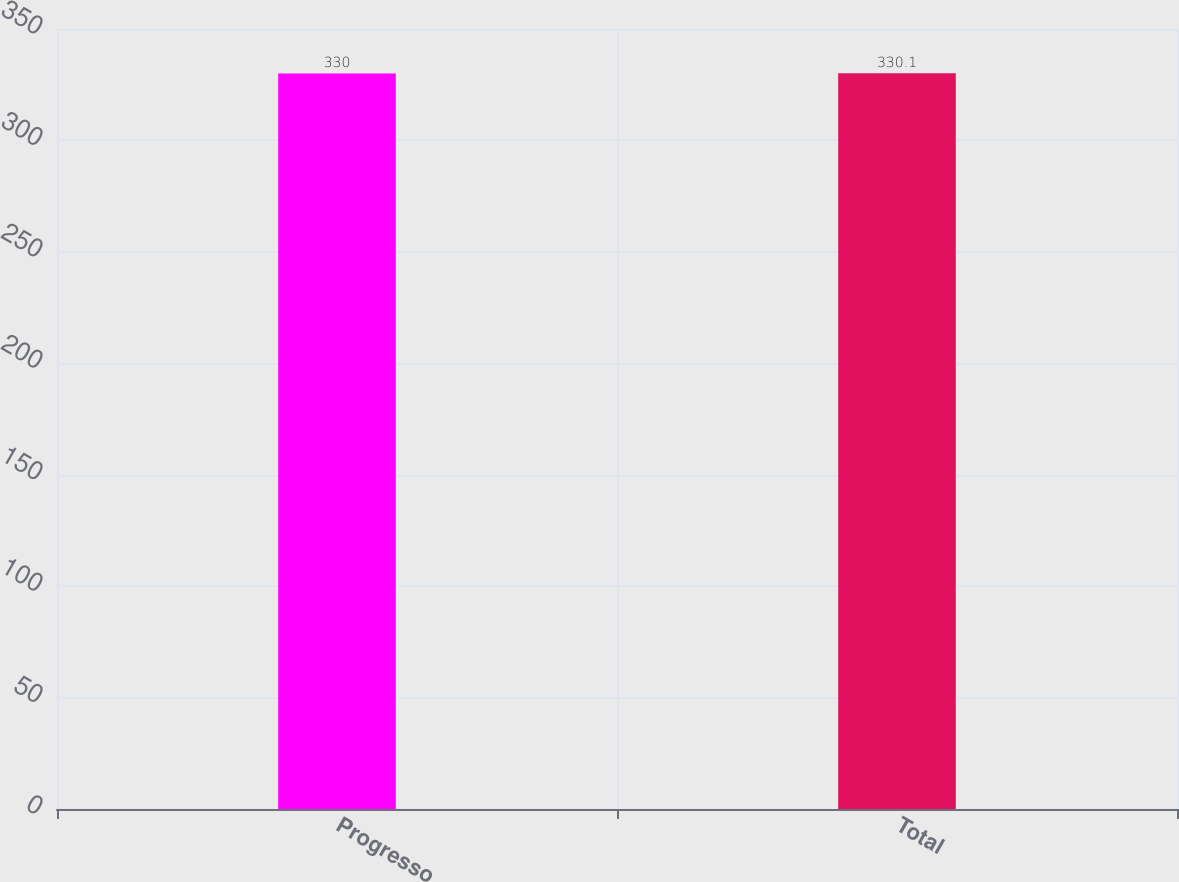<chart> <loc_0><loc_0><loc_500><loc_500><bar_chart><fcel>Progresso<fcel>Total<nl><fcel>330<fcel>330.1<nl></chart> 